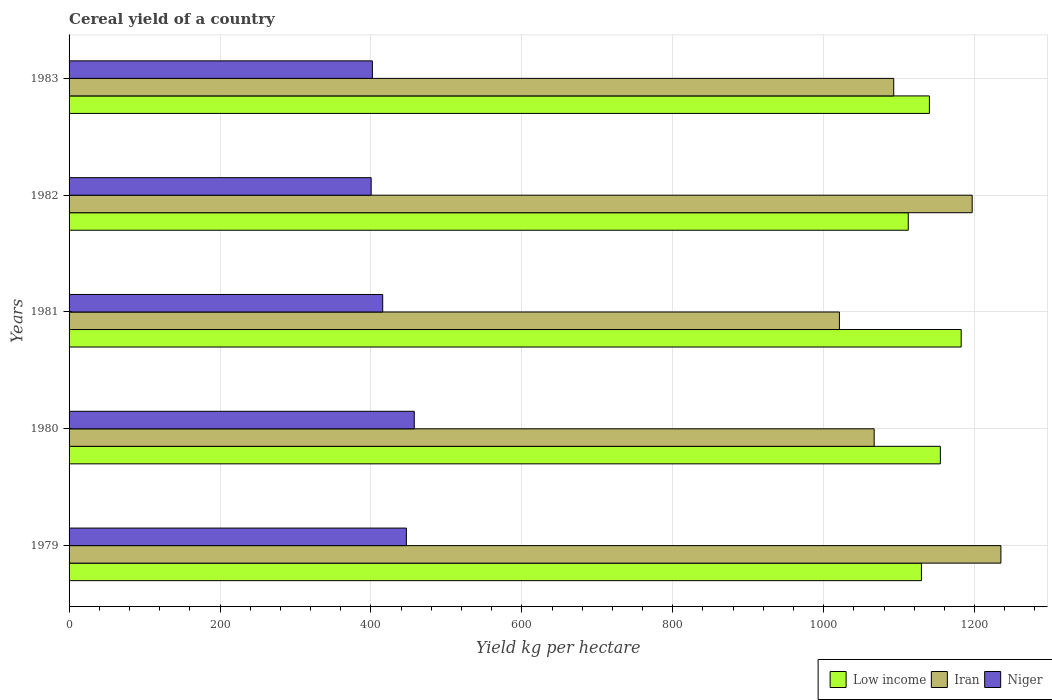How many groups of bars are there?
Provide a short and direct response. 5. Are the number of bars per tick equal to the number of legend labels?
Keep it short and to the point. Yes. How many bars are there on the 4th tick from the top?
Ensure brevity in your answer.  3. In how many cases, is the number of bars for a given year not equal to the number of legend labels?
Offer a terse response. 0. What is the total cereal yield in Iran in 1983?
Offer a very short reply. 1092.81. Across all years, what is the maximum total cereal yield in Niger?
Your answer should be very brief. 457.43. Across all years, what is the minimum total cereal yield in Low income?
Provide a short and direct response. 1112.1. In which year was the total cereal yield in Iran maximum?
Ensure brevity in your answer.  1979. In which year was the total cereal yield in Low income minimum?
Provide a short and direct response. 1982. What is the total total cereal yield in Niger in the graph?
Offer a very short reply. 2122.32. What is the difference between the total cereal yield in Iran in 1981 and that in 1983?
Provide a succinct answer. -71.94. What is the difference between the total cereal yield in Iran in 1980 and the total cereal yield in Low income in 1983?
Your answer should be compact. -73.19. What is the average total cereal yield in Low income per year?
Offer a terse response. 1143.72. In the year 1980, what is the difference between the total cereal yield in Niger and total cereal yield in Low income?
Ensure brevity in your answer.  -697.18. What is the ratio of the total cereal yield in Iran in 1981 to that in 1982?
Offer a very short reply. 0.85. What is the difference between the highest and the second highest total cereal yield in Low income?
Ensure brevity in your answer.  27.62. What is the difference between the highest and the lowest total cereal yield in Iran?
Offer a very short reply. 213.99. What does the 3rd bar from the top in 1982 represents?
Give a very brief answer. Low income. What does the 2nd bar from the bottom in 1983 represents?
Provide a short and direct response. Iran. How many bars are there?
Your answer should be very brief. 15. Are all the bars in the graph horizontal?
Make the answer very short. Yes. How many years are there in the graph?
Keep it short and to the point. 5. Does the graph contain any zero values?
Give a very brief answer. No. Does the graph contain grids?
Provide a short and direct response. Yes. Where does the legend appear in the graph?
Offer a very short reply. Bottom right. How many legend labels are there?
Offer a terse response. 3. How are the legend labels stacked?
Your response must be concise. Horizontal. What is the title of the graph?
Provide a succinct answer. Cereal yield of a country. Does "Croatia" appear as one of the legend labels in the graph?
Offer a very short reply. No. What is the label or title of the X-axis?
Offer a terse response. Yield kg per hectare. What is the Yield kg per hectare in Low income in 1979?
Your answer should be very brief. 1129.54. What is the Yield kg per hectare of Iran in 1979?
Give a very brief answer. 1234.85. What is the Yield kg per hectare in Niger in 1979?
Your response must be concise. 447.02. What is the Yield kg per hectare in Low income in 1980?
Your answer should be very brief. 1154.61. What is the Yield kg per hectare in Iran in 1980?
Ensure brevity in your answer.  1066.91. What is the Yield kg per hectare of Niger in 1980?
Keep it short and to the point. 457.43. What is the Yield kg per hectare of Low income in 1981?
Provide a succinct answer. 1182.23. What is the Yield kg per hectare in Iran in 1981?
Provide a succinct answer. 1020.87. What is the Yield kg per hectare of Niger in 1981?
Offer a terse response. 415.63. What is the Yield kg per hectare in Low income in 1982?
Give a very brief answer. 1112.1. What is the Yield kg per hectare in Iran in 1982?
Offer a terse response. 1196.79. What is the Yield kg per hectare of Niger in 1982?
Provide a short and direct response. 400.31. What is the Yield kg per hectare of Low income in 1983?
Ensure brevity in your answer.  1140.1. What is the Yield kg per hectare in Iran in 1983?
Offer a terse response. 1092.81. What is the Yield kg per hectare in Niger in 1983?
Ensure brevity in your answer.  401.93. Across all years, what is the maximum Yield kg per hectare of Low income?
Your response must be concise. 1182.23. Across all years, what is the maximum Yield kg per hectare in Iran?
Offer a terse response. 1234.85. Across all years, what is the maximum Yield kg per hectare in Niger?
Give a very brief answer. 457.43. Across all years, what is the minimum Yield kg per hectare of Low income?
Provide a short and direct response. 1112.1. Across all years, what is the minimum Yield kg per hectare of Iran?
Offer a very short reply. 1020.87. Across all years, what is the minimum Yield kg per hectare in Niger?
Keep it short and to the point. 400.31. What is the total Yield kg per hectare of Low income in the graph?
Your answer should be compact. 5718.58. What is the total Yield kg per hectare of Iran in the graph?
Offer a very short reply. 5612.23. What is the total Yield kg per hectare of Niger in the graph?
Keep it short and to the point. 2122.32. What is the difference between the Yield kg per hectare in Low income in 1979 and that in 1980?
Offer a very short reply. -25.08. What is the difference between the Yield kg per hectare in Iran in 1979 and that in 1980?
Your response must be concise. 167.94. What is the difference between the Yield kg per hectare in Niger in 1979 and that in 1980?
Ensure brevity in your answer.  -10.41. What is the difference between the Yield kg per hectare of Low income in 1979 and that in 1981?
Offer a very short reply. -52.69. What is the difference between the Yield kg per hectare of Iran in 1979 and that in 1981?
Give a very brief answer. 213.99. What is the difference between the Yield kg per hectare in Niger in 1979 and that in 1981?
Give a very brief answer. 31.39. What is the difference between the Yield kg per hectare of Low income in 1979 and that in 1982?
Provide a short and direct response. 17.44. What is the difference between the Yield kg per hectare of Iran in 1979 and that in 1982?
Provide a succinct answer. 38.06. What is the difference between the Yield kg per hectare of Niger in 1979 and that in 1982?
Offer a very short reply. 46.7. What is the difference between the Yield kg per hectare of Low income in 1979 and that in 1983?
Your answer should be compact. -10.56. What is the difference between the Yield kg per hectare in Iran in 1979 and that in 1983?
Give a very brief answer. 142.04. What is the difference between the Yield kg per hectare of Niger in 1979 and that in 1983?
Your answer should be very brief. 45.09. What is the difference between the Yield kg per hectare in Low income in 1980 and that in 1981?
Offer a very short reply. -27.62. What is the difference between the Yield kg per hectare of Iran in 1980 and that in 1981?
Your response must be concise. 46.05. What is the difference between the Yield kg per hectare in Niger in 1980 and that in 1981?
Give a very brief answer. 41.8. What is the difference between the Yield kg per hectare in Low income in 1980 and that in 1982?
Keep it short and to the point. 42.52. What is the difference between the Yield kg per hectare of Iran in 1980 and that in 1982?
Your answer should be compact. -129.88. What is the difference between the Yield kg per hectare of Niger in 1980 and that in 1982?
Offer a very short reply. 57.12. What is the difference between the Yield kg per hectare of Low income in 1980 and that in 1983?
Provide a short and direct response. 14.51. What is the difference between the Yield kg per hectare in Iran in 1980 and that in 1983?
Your answer should be compact. -25.9. What is the difference between the Yield kg per hectare in Niger in 1980 and that in 1983?
Make the answer very short. 55.5. What is the difference between the Yield kg per hectare of Low income in 1981 and that in 1982?
Provide a succinct answer. 70.13. What is the difference between the Yield kg per hectare in Iran in 1981 and that in 1982?
Offer a very short reply. -175.93. What is the difference between the Yield kg per hectare of Niger in 1981 and that in 1982?
Offer a terse response. 15.31. What is the difference between the Yield kg per hectare in Low income in 1981 and that in 1983?
Offer a terse response. 42.13. What is the difference between the Yield kg per hectare in Iran in 1981 and that in 1983?
Make the answer very short. -71.94. What is the difference between the Yield kg per hectare in Niger in 1981 and that in 1983?
Offer a terse response. 13.7. What is the difference between the Yield kg per hectare of Low income in 1982 and that in 1983?
Offer a terse response. -28. What is the difference between the Yield kg per hectare in Iran in 1982 and that in 1983?
Provide a short and direct response. 103.98. What is the difference between the Yield kg per hectare in Niger in 1982 and that in 1983?
Offer a very short reply. -1.61. What is the difference between the Yield kg per hectare of Low income in 1979 and the Yield kg per hectare of Iran in 1980?
Keep it short and to the point. 62.63. What is the difference between the Yield kg per hectare in Low income in 1979 and the Yield kg per hectare in Niger in 1980?
Provide a short and direct response. 672.11. What is the difference between the Yield kg per hectare of Iran in 1979 and the Yield kg per hectare of Niger in 1980?
Your answer should be compact. 777.42. What is the difference between the Yield kg per hectare of Low income in 1979 and the Yield kg per hectare of Iran in 1981?
Ensure brevity in your answer.  108.67. What is the difference between the Yield kg per hectare of Low income in 1979 and the Yield kg per hectare of Niger in 1981?
Your answer should be compact. 713.91. What is the difference between the Yield kg per hectare in Iran in 1979 and the Yield kg per hectare in Niger in 1981?
Offer a terse response. 819.22. What is the difference between the Yield kg per hectare of Low income in 1979 and the Yield kg per hectare of Iran in 1982?
Your answer should be compact. -67.25. What is the difference between the Yield kg per hectare of Low income in 1979 and the Yield kg per hectare of Niger in 1982?
Provide a short and direct response. 729.22. What is the difference between the Yield kg per hectare of Iran in 1979 and the Yield kg per hectare of Niger in 1982?
Your answer should be compact. 834.54. What is the difference between the Yield kg per hectare of Low income in 1979 and the Yield kg per hectare of Iran in 1983?
Provide a succinct answer. 36.73. What is the difference between the Yield kg per hectare in Low income in 1979 and the Yield kg per hectare in Niger in 1983?
Give a very brief answer. 727.61. What is the difference between the Yield kg per hectare in Iran in 1979 and the Yield kg per hectare in Niger in 1983?
Your response must be concise. 832.92. What is the difference between the Yield kg per hectare in Low income in 1980 and the Yield kg per hectare in Iran in 1981?
Make the answer very short. 133.75. What is the difference between the Yield kg per hectare of Low income in 1980 and the Yield kg per hectare of Niger in 1981?
Give a very brief answer. 738.98. What is the difference between the Yield kg per hectare of Iran in 1980 and the Yield kg per hectare of Niger in 1981?
Make the answer very short. 651.28. What is the difference between the Yield kg per hectare of Low income in 1980 and the Yield kg per hectare of Iran in 1982?
Keep it short and to the point. -42.18. What is the difference between the Yield kg per hectare in Low income in 1980 and the Yield kg per hectare in Niger in 1982?
Offer a terse response. 754.3. What is the difference between the Yield kg per hectare in Iran in 1980 and the Yield kg per hectare in Niger in 1982?
Give a very brief answer. 666.6. What is the difference between the Yield kg per hectare of Low income in 1980 and the Yield kg per hectare of Iran in 1983?
Your response must be concise. 61.81. What is the difference between the Yield kg per hectare in Low income in 1980 and the Yield kg per hectare in Niger in 1983?
Offer a very short reply. 752.69. What is the difference between the Yield kg per hectare in Iran in 1980 and the Yield kg per hectare in Niger in 1983?
Make the answer very short. 664.98. What is the difference between the Yield kg per hectare of Low income in 1981 and the Yield kg per hectare of Iran in 1982?
Give a very brief answer. -14.56. What is the difference between the Yield kg per hectare of Low income in 1981 and the Yield kg per hectare of Niger in 1982?
Ensure brevity in your answer.  781.92. What is the difference between the Yield kg per hectare in Iran in 1981 and the Yield kg per hectare in Niger in 1982?
Your response must be concise. 620.55. What is the difference between the Yield kg per hectare in Low income in 1981 and the Yield kg per hectare in Iran in 1983?
Make the answer very short. 89.42. What is the difference between the Yield kg per hectare of Low income in 1981 and the Yield kg per hectare of Niger in 1983?
Provide a short and direct response. 780.3. What is the difference between the Yield kg per hectare of Iran in 1981 and the Yield kg per hectare of Niger in 1983?
Make the answer very short. 618.94. What is the difference between the Yield kg per hectare of Low income in 1982 and the Yield kg per hectare of Iran in 1983?
Offer a very short reply. 19.29. What is the difference between the Yield kg per hectare of Low income in 1982 and the Yield kg per hectare of Niger in 1983?
Keep it short and to the point. 710.17. What is the difference between the Yield kg per hectare in Iran in 1982 and the Yield kg per hectare in Niger in 1983?
Your answer should be compact. 794.86. What is the average Yield kg per hectare in Low income per year?
Your answer should be compact. 1143.72. What is the average Yield kg per hectare in Iran per year?
Your answer should be very brief. 1122.45. What is the average Yield kg per hectare in Niger per year?
Ensure brevity in your answer.  424.46. In the year 1979, what is the difference between the Yield kg per hectare of Low income and Yield kg per hectare of Iran?
Your answer should be very brief. -105.31. In the year 1979, what is the difference between the Yield kg per hectare in Low income and Yield kg per hectare in Niger?
Your answer should be compact. 682.52. In the year 1979, what is the difference between the Yield kg per hectare of Iran and Yield kg per hectare of Niger?
Provide a short and direct response. 787.83. In the year 1980, what is the difference between the Yield kg per hectare of Low income and Yield kg per hectare of Iran?
Your answer should be very brief. 87.7. In the year 1980, what is the difference between the Yield kg per hectare in Low income and Yield kg per hectare in Niger?
Provide a short and direct response. 697.18. In the year 1980, what is the difference between the Yield kg per hectare in Iran and Yield kg per hectare in Niger?
Offer a terse response. 609.48. In the year 1981, what is the difference between the Yield kg per hectare in Low income and Yield kg per hectare in Iran?
Keep it short and to the point. 161.37. In the year 1981, what is the difference between the Yield kg per hectare in Low income and Yield kg per hectare in Niger?
Offer a terse response. 766.6. In the year 1981, what is the difference between the Yield kg per hectare of Iran and Yield kg per hectare of Niger?
Your answer should be compact. 605.24. In the year 1982, what is the difference between the Yield kg per hectare in Low income and Yield kg per hectare in Iran?
Offer a very short reply. -84.69. In the year 1982, what is the difference between the Yield kg per hectare in Low income and Yield kg per hectare in Niger?
Keep it short and to the point. 711.78. In the year 1982, what is the difference between the Yield kg per hectare in Iran and Yield kg per hectare in Niger?
Provide a short and direct response. 796.48. In the year 1983, what is the difference between the Yield kg per hectare in Low income and Yield kg per hectare in Iran?
Give a very brief answer. 47.29. In the year 1983, what is the difference between the Yield kg per hectare of Low income and Yield kg per hectare of Niger?
Make the answer very short. 738.17. In the year 1983, what is the difference between the Yield kg per hectare of Iran and Yield kg per hectare of Niger?
Offer a terse response. 690.88. What is the ratio of the Yield kg per hectare in Low income in 1979 to that in 1980?
Your answer should be very brief. 0.98. What is the ratio of the Yield kg per hectare of Iran in 1979 to that in 1980?
Your answer should be very brief. 1.16. What is the ratio of the Yield kg per hectare in Niger in 1979 to that in 1980?
Make the answer very short. 0.98. What is the ratio of the Yield kg per hectare in Low income in 1979 to that in 1981?
Give a very brief answer. 0.96. What is the ratio of the Yield kg per hectare of Iran in 1979 to that in 1981?
Give a very brief answer. 1.21. What is the ratio of the Yield kg per hectare in Niger in 1979 to that in 1981?
Ensure brevity in your answer.  1.08. What is the ratio of the Yield kg per hectare of Low income in 1979 to that in 1982?
Make the answer very short. 1.02. What is the ratio of the Yield kg per hectare of Iran in 1979 to that in 1982?
Your answer should be very brief. 1.03. What is the ratio of the Yield kg per hectare in Niger in 1979 to that in 1982?
Your response must be concise. 1.12. What is the ratio of the Yield kg per hectare in Iran in 1979 to that in 1983?
Offer a terse response. 1.13. What is the ratio of the Yield kg per hectare in Niger in 1979 to that in 1983?
Provide a short and direct response. 1.11. What is the ratio of the Yield kg per hectare in Low income in 1980 to that in 1981?
Keep it short and to the point. 0.98. What is the ratio of the Yield kg per hectare of Iran in 1980 to that in 1981?
Keep it short and to the point. 1.05. What is the ratio of the Yield kg per hectare of Niger in 1980 to that in 1981?
Give a very brief answer. 1.1. What is the ratio of the Yield kg per hectare of Low income in 1980 to that in 1982?
Provide a short and direct response. 1.04. What is the ratio of the Yield kg per hectare in Iran in 1980 to that in 1982?
Provide a short and direct response. 0.89. What is the ratio of the Yield kg per hectare of Niger in 1980 to that in 1982?
Keep it short and to the point. 1.14. What is the ratio of the Yield kg per hectare of Low income in 1980 to that in 1983?
Offer a terse response. 1.01. What is the ratio of the Yield kg per hectare of Iran in 1980 to that in 1983?
Make the answer very short. 0.98. What is the ratio of the Yield kg per hectare of Niger in 1980 to that in 1983?
Your answer should be very brief. 1.14. What is the ratio of the Yield kg per hectare in Low income in 1981 to that in 1982?
Your answer should be compact. 1.06. What is the ratio of the Yield kg per hectare of Iran in 1981 to that in 1982?
Provide a succinct answer. 0.85. What is the ratio of the Yield kg per hectare of Niger in 1981 to that in 1982?
Make the answer very short. 1.04. What is the ratio of the Yield kg per hectare of Low income in 1981 to that in 1983?
Your answer should be compact. 1.04. What is the ratio of the Yield kg per hectare of Iran in 1981 to that in 1983?
Give a very brief answer. 0.93. What is the ratio of the Yield kg per hectare in Niger in 1981 to that in 1983?
Your answer should be very brief. 1.03. What is the ratio of the Yield kg per hectare in Low income in 1982 to that in 1983?
Your answer should be very brief. 0.98. What is the ratio of the Yield kg per hectare in Iran in 1982 to that in 1983?
Offer a terse response. 1.1. What is the ratio of the Yield kg per hectare in Niger in 1982 to that in 1983?
Provide a short and direct response. 1. What is the difference between the highest and the second highest Yield kg per hectare of Low income?
Your response must be concise. 27.62. What is the difference between the highest and the second highest Yield kg per hectare of Iran?
Provide a succinct answer. 38.06. What is the difference between the highest and the second highest Yield kg per hectare in Niger?
Offer a very short reply. 10.41. What is the difference between the highest and the lowest Yield kg per hectare in Low income?
Your response must be concise. 70.13. What is the difference between the highest and the lowest Yield kg per hectare of Iran?
Offer a very short reply. 213.99. What is the difference between the highest and the lowest Yield kg per hectare of Niger?
Make the answer very short. 57.12. 